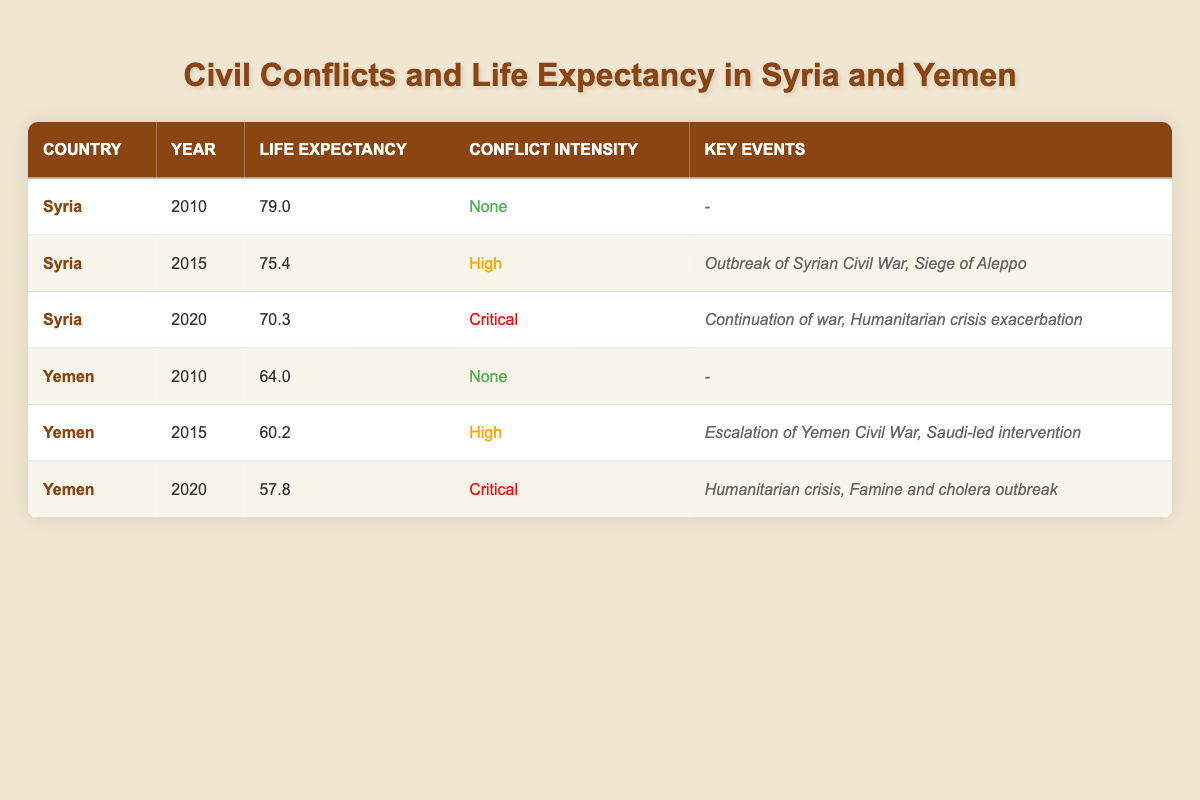What was the life expectancy in Syria in 2010? The table shows that in the year 2010, Syria had a life expectancy of 79.0.
Answer: 79.0 What events were key in Syria during 2015? According to the table, the key events in Syria during 2015 were the outbreak of the Syrian Civil War and the Siege of Aleppo.
Answer: Outbreak of Syrian Civil War, Siege of Aleppo Did Yemen experience any civil conflict in 2010? The table indicates that Yemen had a conflict intensity of "None" in 2010, which means there was no civil conflict during that year.
Answer: No What was the difference in life expectancy between 2015 and 2020 in Yemen? For Yemen, the life expectancy in 2015 was 60.2 and in 2020 it was 57.8. The difference is calculated as 60.2 - 57.8 = 2.4.
Answer: 2.4 Which country had a higher life expectancy in 2020, Syria or Yemen? In 2020, Syria had a life expectancy of 70.3 while Yemen had 57.8. Since 70.3 is greater than 57.8, Syria had the higher life expectancy.
Answer: Syria What was the average life expectancy in Syria over the years 2010 to 2020? The life expectancy values for Syria are 79.0 (2010), 75.4 (2015), and 70.3 (2020). To find the average, sum these values: 79.0 + 75.4 + 70.3 = 224.7, and then divide by 3, resulting in 224.7 / 3 = 74.9.
Answer: 74.9 Did the life expectancy in Syria decrease from 2010 to 2015? In 2010, Syria had a life expectancy of 79.0, and in 2015 it decreased to 75.4. Since 75.4 is less than 79.0, the life expectancy did indeed decrease during this period.
Answer: Yes What was the trend of life expectancy in Yemen from 2010 to 2020? In Yemen, the life expectancy decreased from 64.0 in 2010 to 60.2 in 2015, and further decreased to 57.8 in 2020. This shows a continuous decline over the decade.
Answer: Continuous decline What was the conflict intensity in both countries in 2010? The table indicates that in 2010, both Syria and Yemen had a conflict intensity of "None".
Answer: None for both 